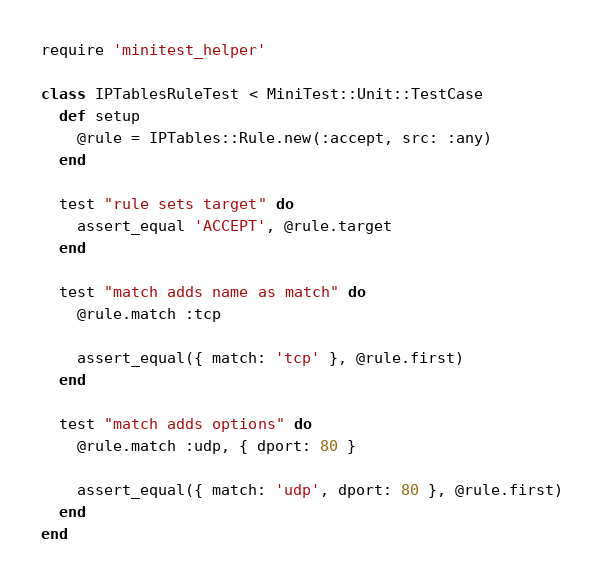Convert code to text. <code><loc_0><loc_0><loc_500><loc_500><_Ruby_>require 'minitest_helper'

class IPTablesRuleTest < MiniTest::Unit::TestCase
  def setup
    @rule = IPTables::Rule.new(:accept, src: :any)
  end

  test "rule sets target" do
    assert_equal 'ACCEPT', @rule.target
  end

  test "match adds name as match" do
    @rule.match :tcp

    assert_equal({ match: 'tcp' }, @rule.first)
  end

  test "match adds options" do
    @rule.match :udp, { dport: 80 }

    assert_equal({ match: 'udp', dport: 80 }, @rule.first)
  end
end
</code> 